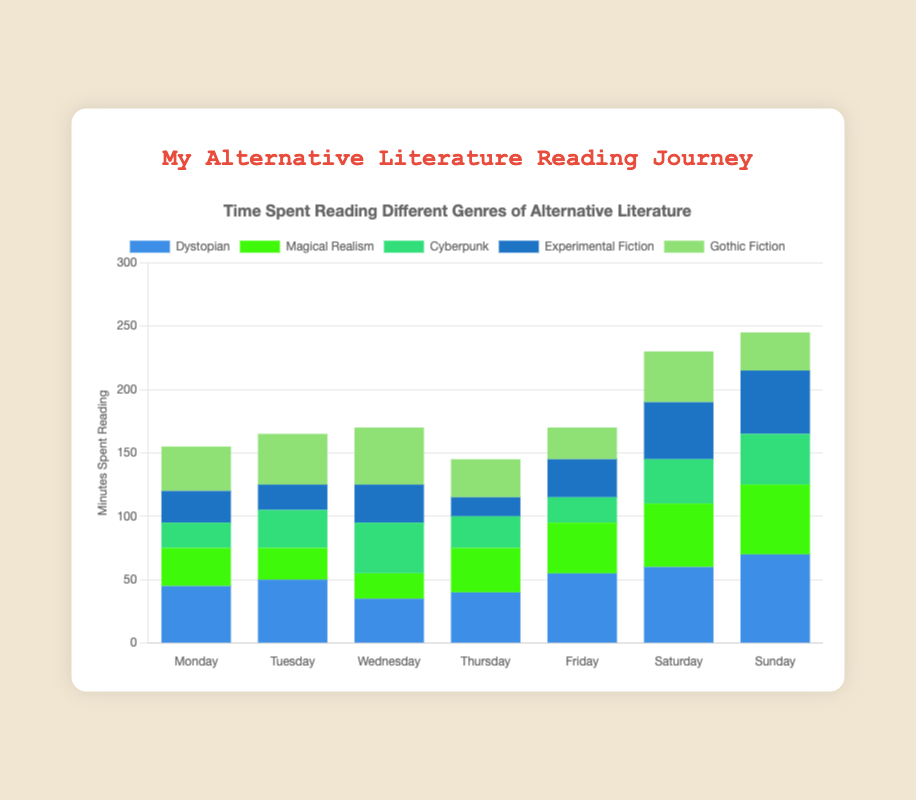How many minutes did I spend reading Gothic Fiction throughout the week? Sum the minutes spent on Gothic Fiction for each day: 35 (Mon) + 40 (Tue) + 45 (Wed) + 30 (Thu) + 25 (Fri) + 40 (Sat) + 30 (Sun). The total is 245 minutes.
Answer: 245 On which day did I spend the most time reading Dystopian literature? Compare the minutes spent on Dystopian literature each day: 45 (Mon), 50 (Tue), 35 (Wed), 40 (Thu), 55 (Fri), 60 (Sat), 70 (Sun). Sunday has the highest value with 70 minutes.
Answer: Sunday Between Saturdays and Sundays, which genre saw the biggest increase in reading time? Calculate the difference in reading time for each genre between Saturday and Sunday: 
- Dystopian: 70 - 60 = 10
- Magical Realism: 55 - 50 = 5
- Cyberpunk: 40 - 35 = 5
- Experimental Fiction: 50 - 45 = 5
- Gothic Fiction: 30 - 40 = -10 
The biggest increase is in Dystopian with 10 minutes.
Answer: Dystopian What is the average time spent reading Magical Realism each day? Sum the time spent reading Magical Realism: 30 (Mon) + 25 (Tue) + 20 (Wed) + 35 (Thu) + 40 (Fri) + 50 (Sat) + 55 (Sun) = 255. Divide by 7 days: 255 / 7 = 36.43
Answer: 36.43 Which genre had the least reading time on Thursday? Compare the reading times for Thursday: 40 (Dystopian), 35 (Magical Realism), 25 (Cyberpunk), 15 (Experimental Fiction), 30 (Gothic Fiction). Experimental Fiction has the least with 15 minutes.
Answer: Experimental Fiction By how many minutes did my reading time for Cyberpunk increase from Monday to Wednesday? Calculate the difference in reading time for Cyberpunk between Monday and Wednesday: 40 (Wed) - 20 (Mon) = 20 minutes.
Answer: 20 Comparing Tuesday and Friday, which genre’s reading time decreased? Compare the reading times for Tuesday and Friday:
- Dystopian: 55 - 50 = 5 (increase)
- Magical Realism: 40 - 25 = 15 (increase)
- Cyberpunk: 20 - 30 = -10 (decrease)
- Experimental Fiction: 30 - 20 = 10 (increase)
- Gothic Fiction: 25 - 40 = -15 (decrease)
Cyberpunk and Gothic Fiction both saw a decrease.
Answer: Cyberpunk, Gothic Fiction Which day's stack is the shortest in height, indicating the least total reading time? Calculate the total reading time per day and compare:
- Monday: 45 + 30 + 20 + 25 + 35 = 155
- Tuesday: 50 + 25 + 30 + 20 + 40 = 165
- Wednesday: 35 + 20 + 40 + 30 + 45 = 170
- Thursday: 40 + 35 + 25 + 15 + 30 = 145
- Friday: 55 + 40 + 20 + 30 + 25 = 170
- Saturday: 60 + 50 + 35 + 45 + 40 = 230
- Sunday: 70 + 55 + 40 + 50 + 30 = 245
Thursday has the shortest stack (145 minutes).
Answer: Thursday 